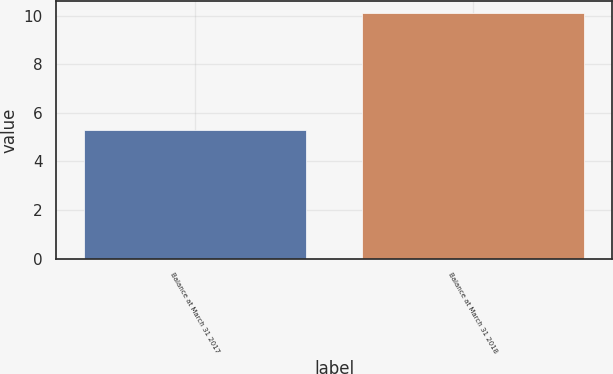Convert chart to OTSL. <chart><loc_0><loc_0><loc_500><loc_500><bar_chart><fcel>Balance at March 31 2017<fcel>Balance at March 31 2018<nl><fcel>5.3<fcel>10.1<nl></chart> 